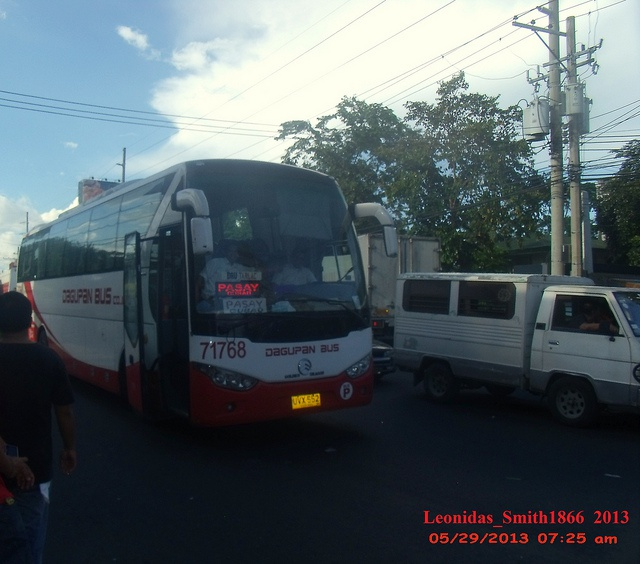Describe the objects in this image and their specific colors. I can see bus in lightblue, black, blue, and darkblue tones, truck in lightblue, black, gray, blue, and darkblue tones, people in lightblue, black, gray, maroon, and darkgray tones, people in lightblue, blue, black, and darkblue tones, and people in darkblue, black, navy, and lightblue tones in this image. 